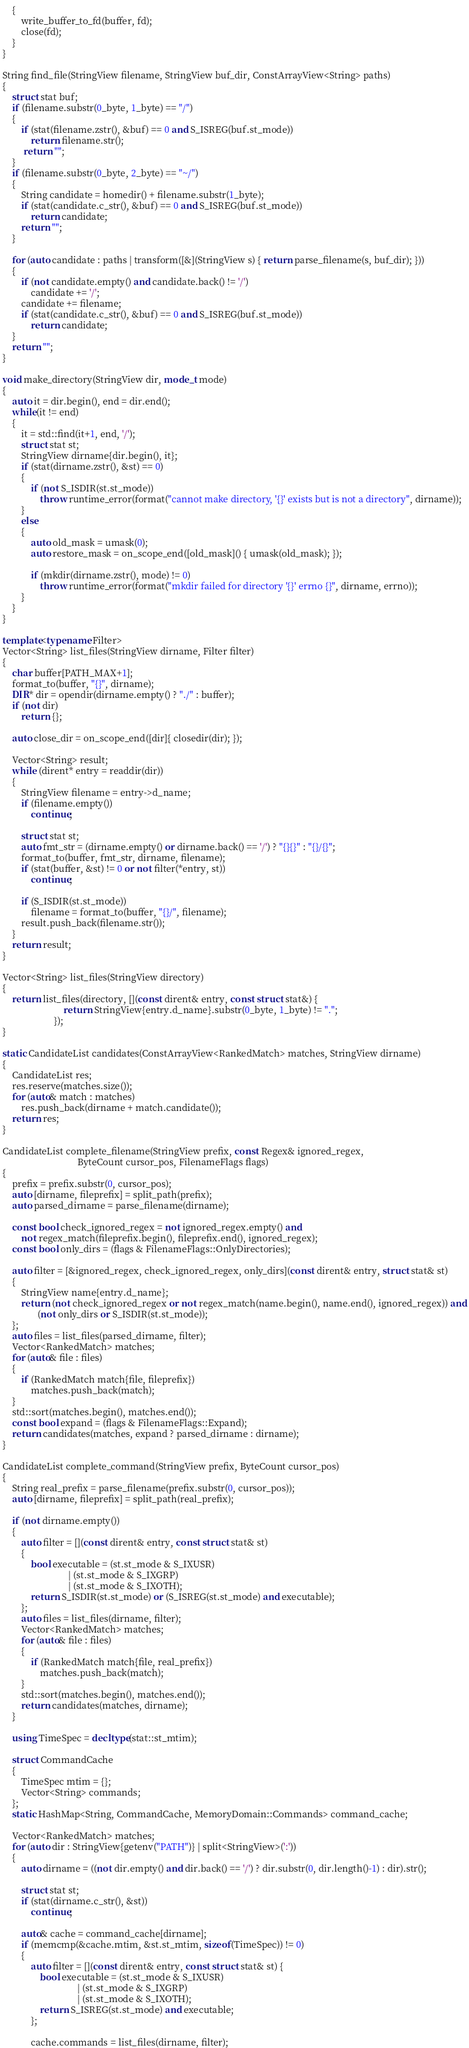Convert code to text. <code><loc_0><loc_0><loc_500><loc_500><_C++_>    {
        write_buffer_to_fd(buffer, fd);
        close(fd);
    }
}

String find_file(StringView filename, StringView buf_dir, ConstArrayView<String> paths)
{
    struct stat buf;
    if (filename.substr(0_byte, 1_byte) == "/")
    {
        if (stat(filename.zstr(), &buf) == 0 and S_ISREG(buf.st_mode))
            return filename.str();
         return "";
    }
    if (filename.substr(0_byte, 2_byte) == "~/")
    {
        String candidate = homedir() + filename.substr(1_byte);
        if (stat(candidate.c_str(), &buf) == 0 and S_ISREG(buf.st_mode))
            return candidate;
        return "";
    }

    for (auto candidate : paths | transform([&](StringView s) { return parse_filename(s, buf_dir); }))
    {
        if (not candidate.empty() and candidate.back() != '/')
            candidate += '/';
        candidate += filename;
        if (stat(candidate.c_str(), &buf) == 0 and S_ISREG(buf.st_mode))
            return candidate;
    }
    return "";
}

void make_directory(StringView dir, mode_t mode)
{
    auto it = dir.begin(), end = dir.end();
    while(it != end)
    {
        it = std::find(it+1, end, '/');
        struct stat st;
        StringView dirname{dir.begin(), it};
        if (stat(dirname.zstr(), &st) == 0)
        {
            if (not S_ISDIR(st.st_mode))
                throw runtime_error(format("cannot make directory, '{}' exists but is not a directory", dirname));
        }
        else
        {
            auto old_mask = umask(0);
            auto restore_mask = on_scope_end([old_mask]() { umask(old_mask); });

            if (mkdir(dirname.zstr(), mode) != 0)
                throw runtime_error(format("mkdir failed for directory '{}' errno {}", dirname, errno));
        }
    }
}

template<typename Filter>
Vector<String> list_files(StringView dirname, Filter filter)
{
    char buffer[PATH_MAX+1];
    format_to(buffer, "{}", dirname);
    DIR* dir = opendir(dirname.empty() ? "./" : buffer);
    if (not dir)
        return {};

    auto close_dir = on_scope_end([dir]{ closedir(dir); });

    Vector<String> result;
    while (dirent* entry = readdir(dir))
    {
        StringView filename = entry->d_name;
        if (filename.empty())
            continue;

        struct stat st;
        auto fmt_str = (dirname.empty() or dirname.back() == '/') ? "{}{}" : "{}/{}";
        format_to(buffer, fmt_str, dirname, filename);
        if (stat(buffer, &st) != 0 or not filter(*entry, st))
            continue;

        if (S_ISDIR(st.st_mode))
            filename = format_to(buffer, "{}/", filename);
        result.push_back(filename.str());
    }
    return result;
}

Vector<String> list_files(StringView directory)
{
    return list_files(directory, [](const dirent& entry, const struct stat&) {
                          return StringView{entry.d_name}.substr(0_byte, 1_byte) != ".";
                      });
}

static CandidateList candidates(ConstArrayView<RankedMatch> matches, StringView dirname)
{
    CandidateList res;
    res.reserve(matches.size());
    for (auto& match : matches)
        res.push_back(dirname + match.candidate());
    return res;
}

CandidateList complete_filename(StringView prefix, const Regex& ignored_regex,
                                ByteCount cursor_pos, FilenameFlags flags)
{
    prefix = prefix.substr(0, cursor_pos);
    auto [dirname, fileprefix] = split_path(prefix);
    auto parsed_dirname = parse_filename(dirname);

    const bool check_ignored_regex = not ignored_regex.empty() and
        not regex_match(fileprefix.begin(), fileprefix.end(), ignored_regex);
    const bool only_dirs = (flags & FilenameFlags::OnlyDirectories);

    auto filter = [&ignored_regex, check_ignored_regex, only_dirs](const dirent& entry, struct stat& st)
    {
        StringView name{entry.d_name};
        return (not check_ignored_regex or not regex_match(name.begin(), name.end(), ignored_regex)) and
               (not only_dirs or S_ISDIR(st.st_mode));
    };
    auto files = list_files(parsed_dirname, filter);
    Vector<RankedMatch> matches;
    for (auto& file : files)
    {
        if (RankedMatch match{file, fileprefix})
            matches.push_back(match);
    }
    std::sort(matches.begin(), matches.end());
    const bool expand = (flags & FilenameFlags::Expand);
    return candidates(matches, expand ? parsed_dirname : dirname);
}

CandidateList complete_command(StringView prefix, ByteCount cursor_pos)
{
    String real_prefix = parse_filename(prefix.substr(0, cursor_pos));
    auto [dirname, fileprefix] = split_path(real_prefix);

    if (not dirname.empty())
    {
        auto filter = [](const dirent& entry, const struct stat& st)
        {
            bool executable = (st.st_mode & S_IXUSR)
                            | (st.st_mode & S_IXGRP)
                            | (st.st_mode & S_IXOTH);
            return S_ISDIR(st.st_mode) or (S_ISREG(st.st_mode) and executable);
        };
        auto files = list_files(dirname, filter);
        Vector<RankedMatch> matches;
        for (auto& file : files)
        {
            if (RankedMatch match{file, real_prefix})
                matches.push_back(match);
        }
        std::sort(matches.begin(), matches.end());
        return candidates(matches, dirname);
    }

    using TimeSpec = decltype(stat::st_mtim);

    struct CommandCache
    {
        TimeSpec mtim = {};
        Vector<String> commands;
    };
    static HashMap<String, CommandCache, MemoryDomain::Commands> command_cache;

    Vector<RankedMatch> matches;
    for (auto dir : StringView{getenv("PATH")} | split<StringView>(':'))
    {
        auto dirname = ((not dir.empty() and dir.back() == '/') ? dir.substr(0, dir.length()-1) : dir).str();

        struct stat st;
        if (stat(dirname.c_str(), &st))
            continue;

        auto& cache = command_cache[dirname];
        if (memcmp(&cache.mtim, &st.st_mtim, sizeof(TimeSpec)) != 0)
        {
            auto filter = [](const dirent& entry, const struct stat& st) {
                bool executable = (st.st_mode & S_IXUSR)
                                | (st.st_mode & S_IXGRP)
                                | (st.st_mode & S_IXOTH);
                return S_ISREG(st.st_mode) and executable;
            };

            cache.commands = list_files(dirname, filter);</code> 